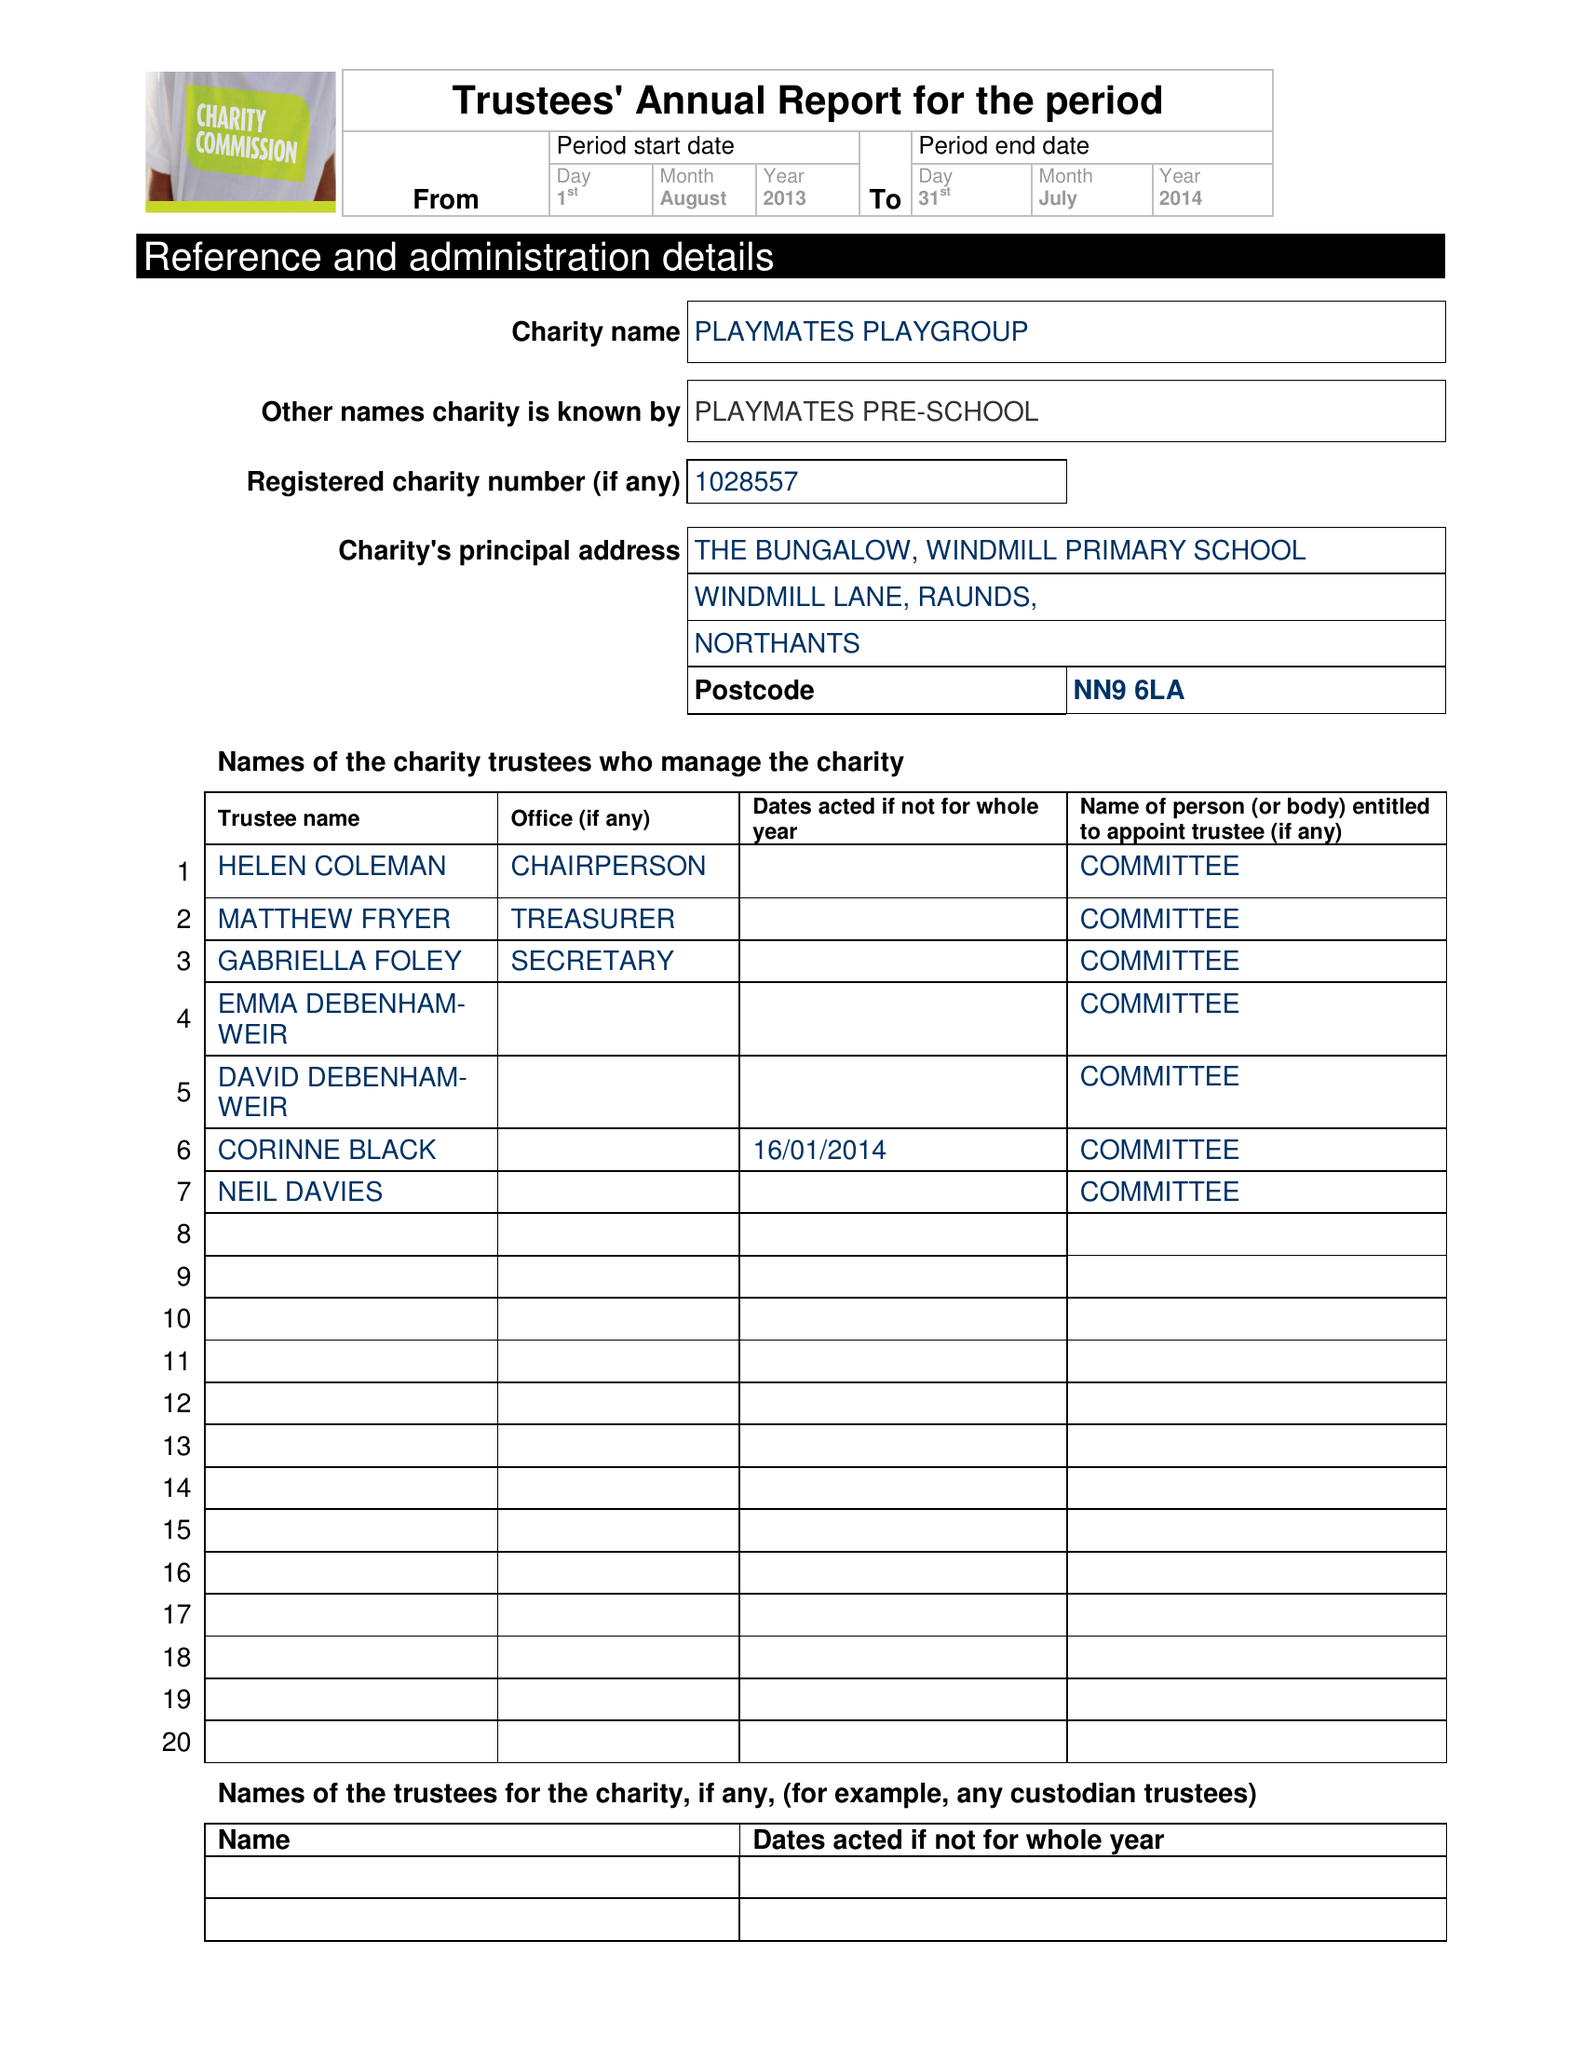What is the value for the address__post_town?
Answer the question using a single word or phrase. WELLINGBOROUGH 